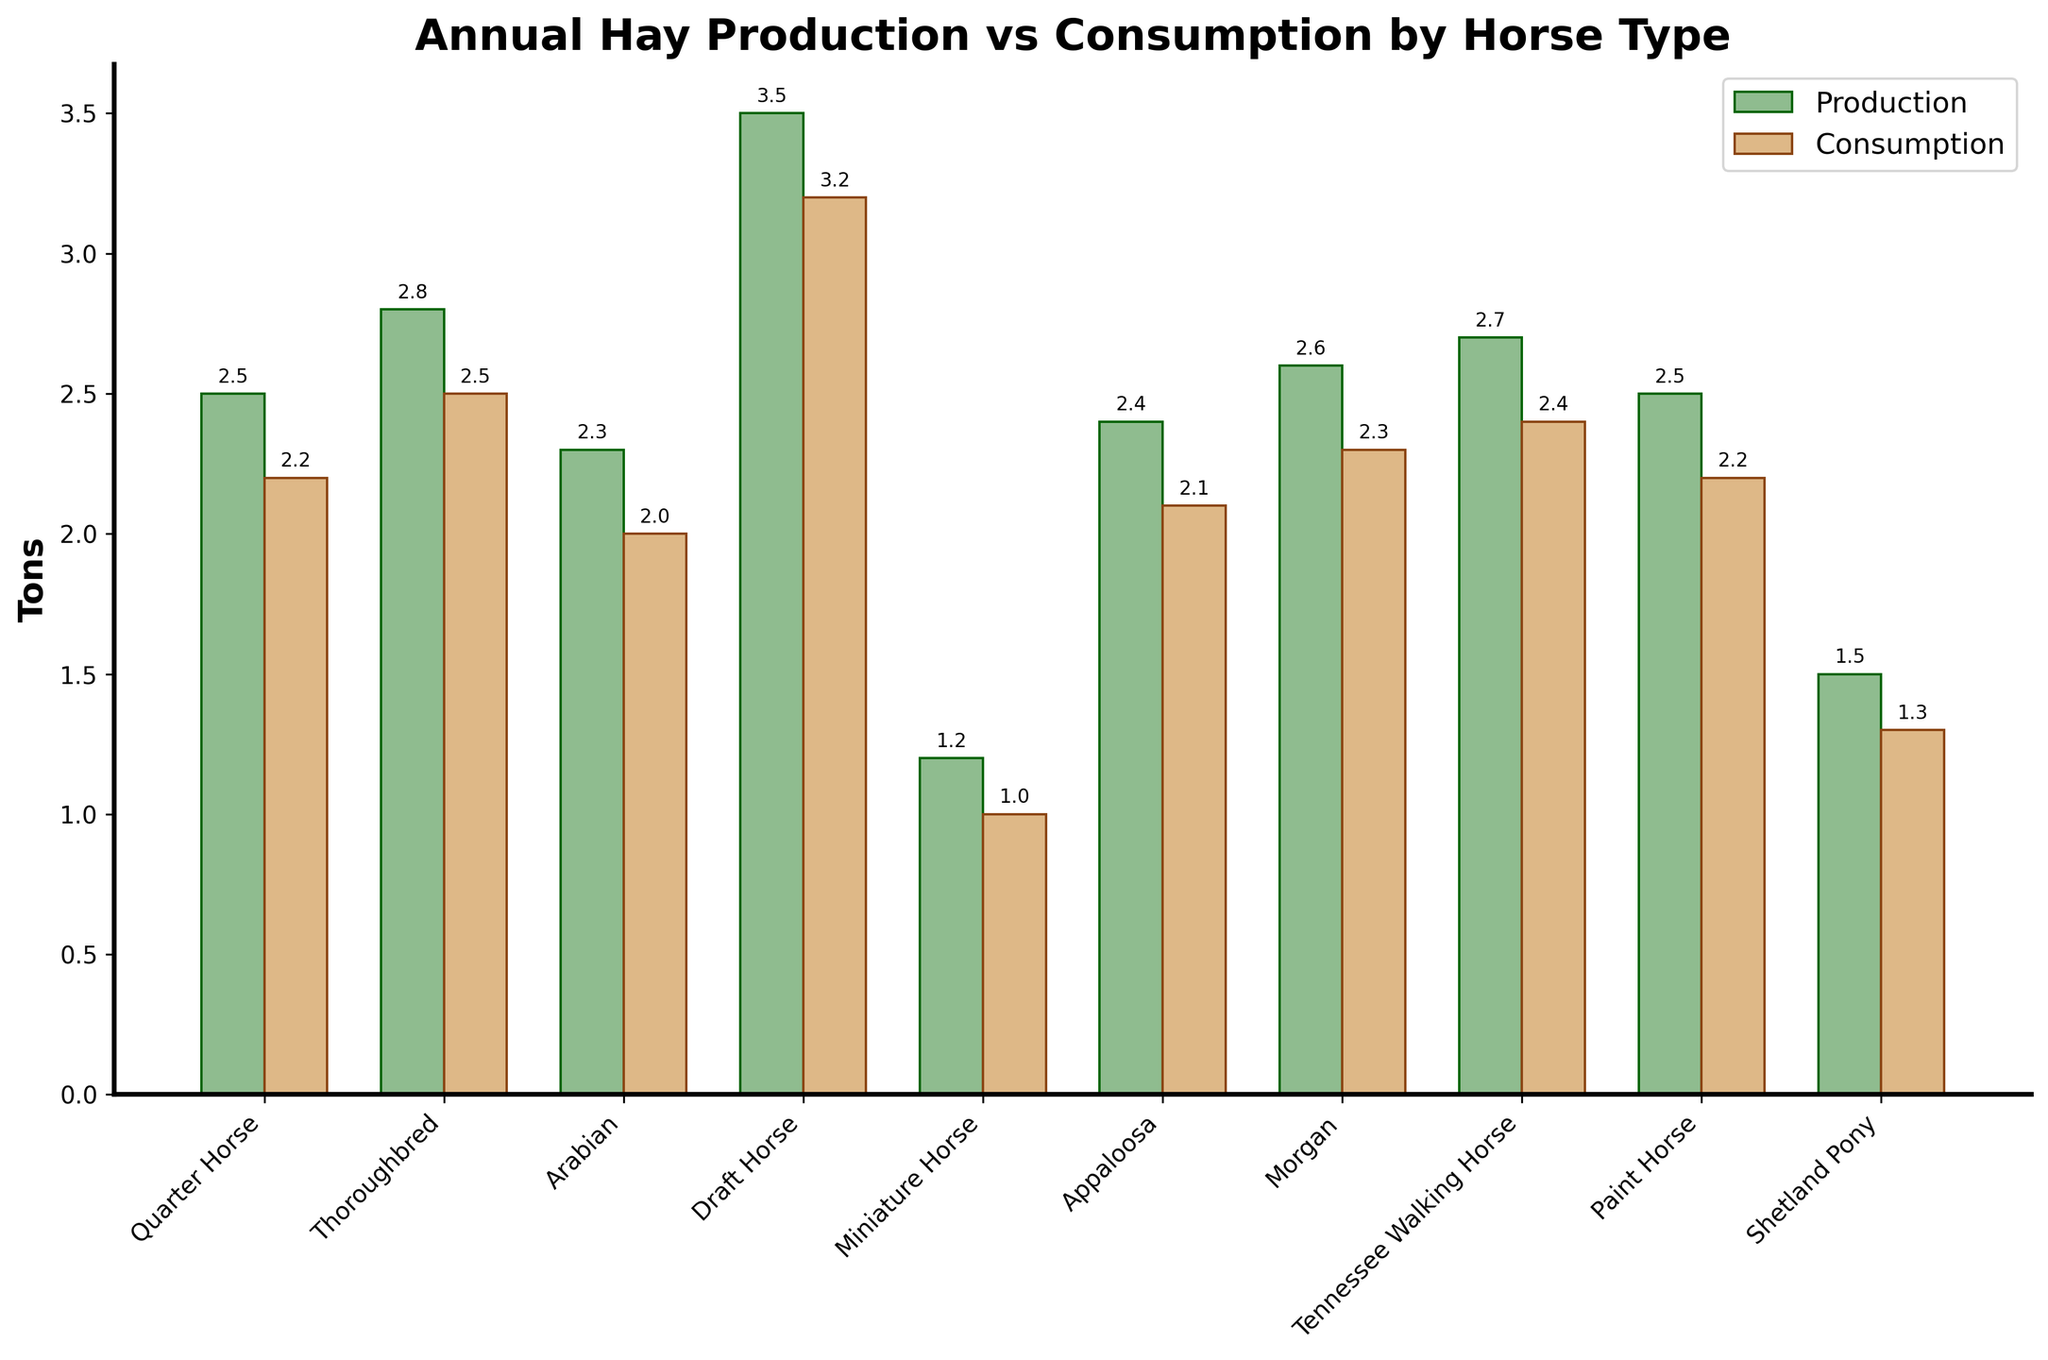Which horse type has the highest annual hay production? The bar representing the Draft Horse has the highest height in the production category.
Answer: Draft Horse Which horse type has the lowest annual hay consumption? The bar representing the Miniature Horse has the lowest height in the consumption category.
Answer: Miniature Horse What is the difference in annual hay consumption between the Thoroughbred and the Quarter Horse? The Thoroughbred consumes 2.5 tons and the Quarter Horse consumes 2.2 tons. The difference is 2.5 - 2.2 = 0.3 tons.
Answer: 0.3 tons Which horse type has a higher annual hay production, Morgan or Paint Horse? The Morgan has a production height corresponding to 2.6 tons, while the Paint Horse has a production height corresponding to 2.5 tons.
Answer: Morgan What is the average annual hay consumption of the Shetland Pony, Quarter Horse, and Tennessee Walking Horse? The consumptions are 1.3, 2.2, and 2.4 tons respectively. The average is (1.3 + 2.2 + 2.4) / 3 = 1.97 tons.
Answer: 1.97 tons How much more annual hay does the Draft Horse consume compared to the Arabian? The Draft Horse consumes 3.2 tons, while the Arabian consumes 2.0 tons. The difference is 3.2 - 2.0 = 1.2 tons.
Answer: 1.2 tons Which horse types have their annual hay production and consumption equal? None of the bars in the production and consumption categories have exactly the same height for any horse type.
Answer: None What is the combined annual hay production of the Appaloosa, Morgan, and Tennessee Walking Horse? The productions are 2.4, 2.6, and 2.7 tons respectively. The sum is 2.4 + 2.6 + 2.7 = 7.7 tons.
Answer: 7.7 tons Which horse type has the smallest difference between annual hay production and consumption? The Miniature Horse has a production of 1.2 tons and consumption of 1.0 tons, with a difference of 0.2 tons, which is the smallest difference.
Answer: Miniature Horse Does the Paint Horse consume more hay annually than the Appaloosa? Both the Paint Horse and the Appaloosa have the same annual consumption of 2.2 tons.
Answer: No 